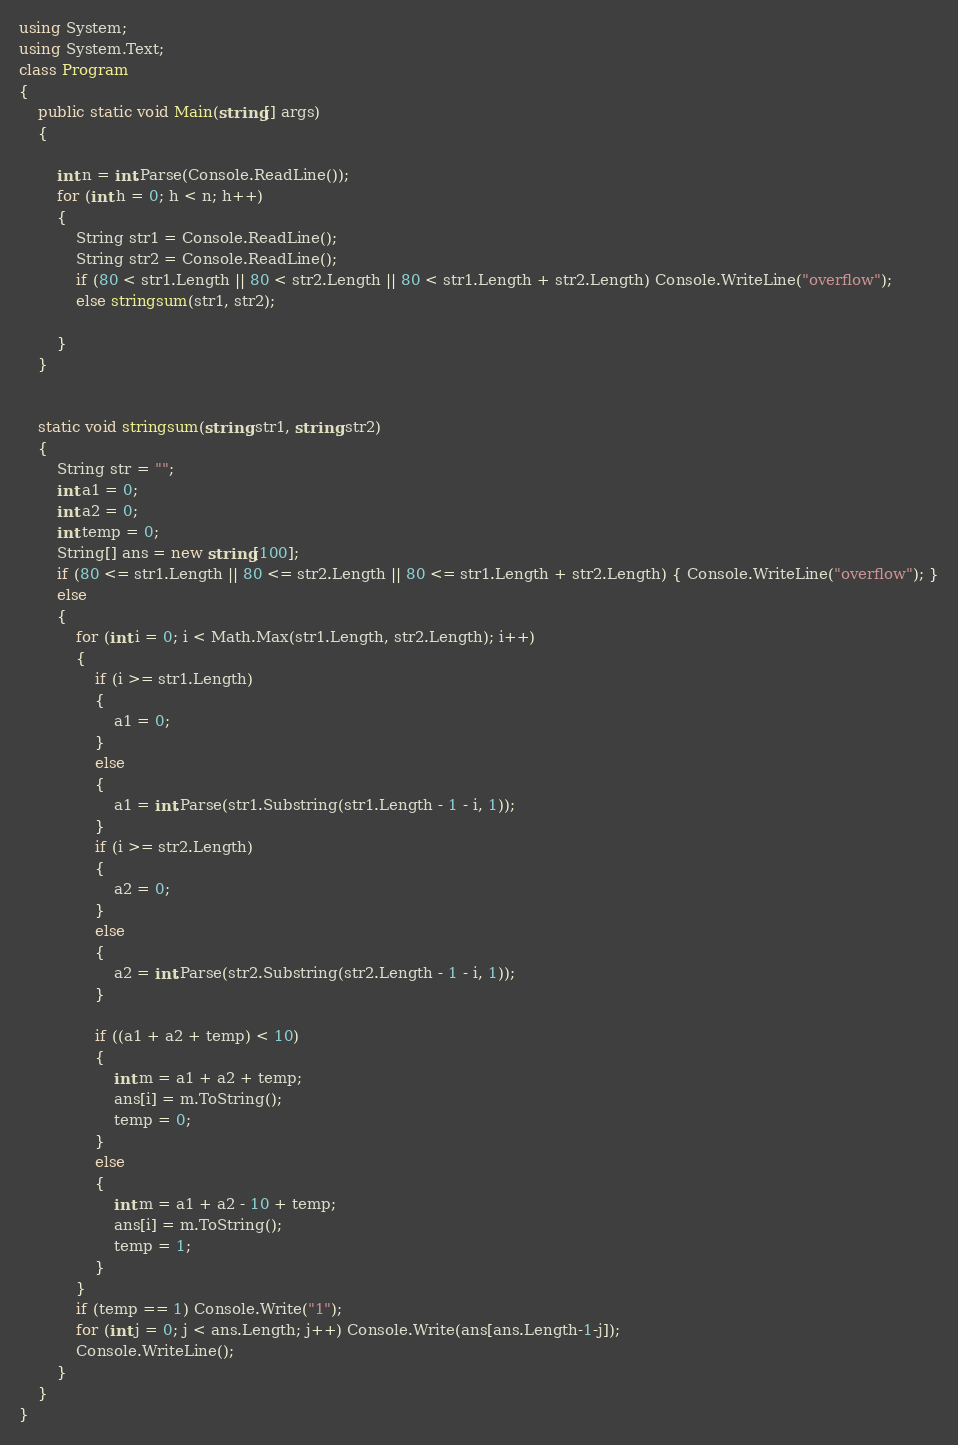<code> <loc_0><loc_0><loc_500><loc_500><_C#_>using System;
using System.Text;
class Program
{
    public static void Main(string[] args)
    {

        int n = int.Parse(Console.ReadLine());
        for (int h = 0; h < n; h++)
        {
            String str1 = Console.ReadLine();
            String str2 = Console.ReadLine();
            if (80 < str1.Length || 80 < str2.Length || 80 < str1.Length + str2.Length) Console.WriteLine("overflow");
            else stringsum(str1, str2);
            
        }
    }


    static void stringsum(string str1, string str2)
    {
        String str = "";
        int a1 = 0;
        int a2 = 0;
        int temp = 0;
        String[] ans = new string[100];
        if (80 <= str1.Length || 80 <= str2.Length || 80 <= str1.Length + str2.Length) { Console.WriteLine("overflow"); }
        else
        {
            for (int i = 0; i < Math.Max(str1.Length, str2.Length); i++)
            {
                if (i >= str1.Length)
                {
                    a1 = 0;
                }
                else
                {
                    a1 = int.Parse(str1.Substring(str1.Length - 1 - i, 1));
                }
                if (i >= str2.Length)
                {
                    a2 = 0;
                }
                else
                {
                    a2 = int.Parse(str2.Substring(str2.Length - 1 - i, 1));
                }

                if ((a1 + a2 + temp) < 10)
                {
                    int m = a1 + a2 + temp;
                    ans[i] = m.ToString();
                    temp = 0;
                }
                else
                {
                    int m = a1 + a2 - 10 + temp;
                    ans[i] = m.ToString();
                    temp = 1;
                }
            }
            if (temp == 1) Console.Write("1");
            for (int j = 0; j < ans.Length; j++) Console.Write(ans[ans.Length-1-j]);
            Console.WriteLine();
        }
    }
}</code> 